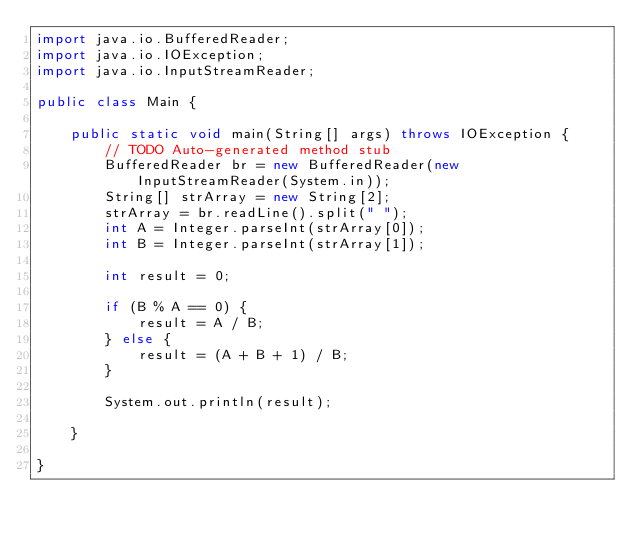<code> <loc_0><loc_0><loc_500><loc_500><_Java_>import java.io.BufferedReader;
import java.io.IOException;
import java.io.InputStreamReader;

public class Main {

	public static void main(String[] args) throws IOException {
		// TODO Auto-generated method stub
		BufferedReader br = new BufferedReader(new InputStreamReader(System.in));
		String[] strArray = new String[2];
		strArray = br.readLine().split(" ");
		int A = Integer.parseInt(strArray[0]);
		int B = Integer.parseInt(strArray[1]);

		int result = 0;

		if (B % A == 0) {
			result = A / B;
		} else {
			result = (A + B + 1) / B;
		}

		System.out.println(result);

	}

}
</code> 